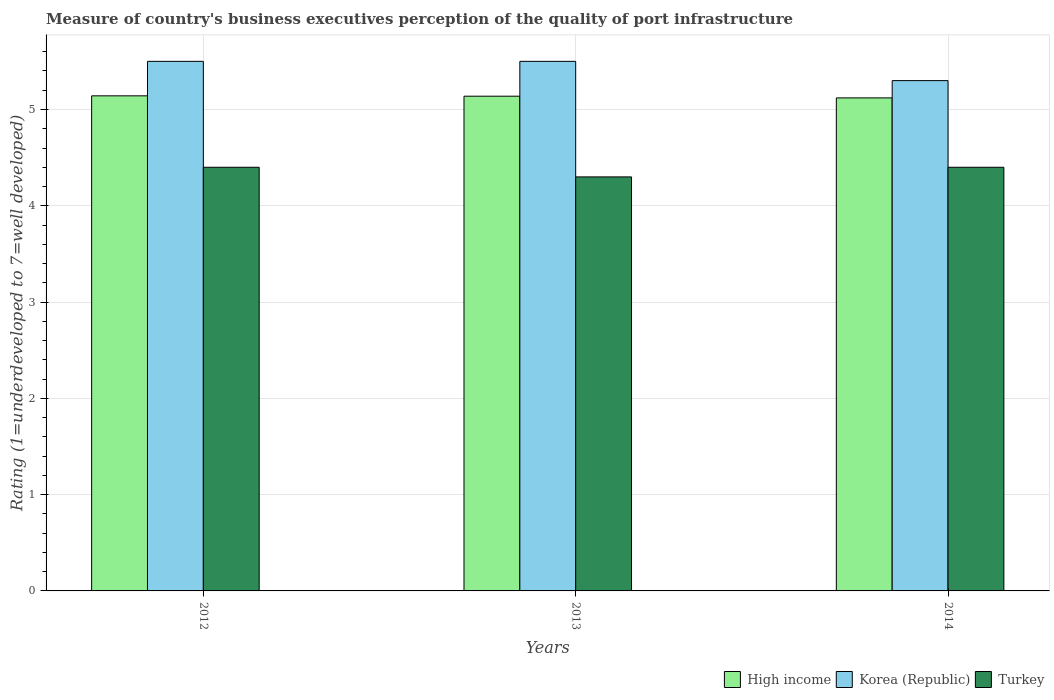How many different coloured bars are there?
Your answer should be very brief. 3. How many groups of bars are there?
Ensure brevity in your answer.  3. How many bars are there on the 3rd tick from the right?
Ensure brevity in your answer.  3. In how many cases, is the number of bars for a given year not equal to the number of legend labels?
Offer a very short reply. 0. What is the ratings of the quality of port infrastructure in High income in 2012?
Your answer should be very brief. 5.14. What is the difference between the ratings of the quality of port infrastructure in Korea (Republic) in 2013 and that in 2014?
Give a very brief answer. 0.2. What is the difference between the ratings of the quality of port infrastructure in Turkey in 2012 and the ratings of the quality of port infrastructure in Korea (Republic) in 2013?
Provide a succinct answer. -1.1. What is the average ratings of the quality of port infrastructure in Turkey per year?
Your response must be concise. 4.37. In the year 2014, what is the difference between the ratings of the quality of port infrastructure in High income and ratings of the quality of port infrastructure in Turkey?
Your response must be concise. 0.72. In how many years, is the ratings of the quality of port infrastructure in High income greater than 3.4?
Your response must be concise. 3. What is the ratio of the ratings of the quality of port infrastructure in Korea (Republic) in 2012 to that in 2014?
Your answer should be compact. 1.04. What is the difference between the highest and the second highest ratings of the quality of port infrastructure in High income?
Provide a short and direct response. 0. What is the difference between the highest and the lowest ratings of the quality of port infrastructure in Turkey?
Offer a terse response. 0.1. In how many years, is the ratings of the quality of port infrastructure in High income greater than the average ratings of the quality of port infrastructure in High income taken over all years?
Your response must be concise. 2. What does the 2nd bar from the left in 2014 represents?
Keep it short and to the point. Korea (Republic). What does the 3rd bar from the right in 2014 represents?
Provide a succinct answer. High income. Is it the case that in every year, the sum of the ratings of the quality of port infrastructure in Turkey and ratings of the quality of port infrastructure in Korea (Republic) is greater than the ratings of the quality of port infrastructure in High income?
Offer a terse response. Yes. How many bars are there?
Provide a succinct answer. 9. Are all the bars in the graph horizontal?
Provide a short and direct response. No. Are the values on the major ticks of Y-axis written in scientific E-notation?
Ensure brevity in your answer.  No. Where does the legend appear in the graph?
Make the answer very short. Bottom right. What is the title of the graph?
Your answer should be compact. Measure of country's business executives perception of the quality of port infrastructure. Does "Qatar" appear as one of the legend labels in the graph?
Your answer should be compact. No. What is the label or title of the Y-axis?
Your response must be concise. Rating (1=underdeveloped to 7=well developed). What is the Rating (1=underdeveloped to 7=well developed) in High income in 2012?
Offer a very short reply. 5.14. What is the Rating (1=underdeveloped to 7=well developed) in Turkey in 2012?
Provide a short and direct response. 4.4. What is the Rating (1=underdeveloped to 7=well developed) of High income in 2013?
Your response must be concise. 5.14. What is the Rating (1=underdeveloped to 7=well developed) of Turkey in 2013?
Give a very brief answer. 4.3. What is the Rating (1=underdeveloped to 7=well developed) of High income in 2014?
Keep it short and to the point. 5.12. What is the Rating (1=underdeveloped to 7=well developed) of Turkey in 2014?
Offer a very short reply. 4.4. Across all years, what is the maximum Rating (1=underdeveloped to 7=well developed) in High income?
Keep it short and to the point. 5.14. Across all years, what is the maximum Rating (1=underdeveloped to 7=well developed) of Korea (Republic)?
Provide a short and direct response. 5.5. Across all years, what is the minimum Rating (1=underdeveloped to 7=well developed) in High income?
Make the answer very short. 5.12. Across all years, what is the minimum Rating (1=underdeveloped to 7=well developed) of Korea (Republic)?
Provide a short and direct response. 5.3. What is the total Rating (1=underdeveloped to 7=well developed) of High income in the graph?
Your response must be concise. 15.4. What is the total Rating (1=underdeveloped to 7=well developed) of Turkey in the graph?
Keep it short and to the point. 13.1. What is the difference between the Rating (1=underdeveloped to 7=well developed) in High income in 2012 and that in 2013?
Offer a very short reply. 0. What is the difference between the Rating (1=underdeveloped to 7=well developed) in Korea (Republic) in 2012 and that in 2013?
Provide a succinct answer. 0. What is the difference between the Rating (1=underdeveloped to 7=well developed) of Turkey in 2012 and that in 2013?
Offer a very short reply. 0.1. What is the difference between the Rating (1=underdeveloped to 7=well developed) of High income in 2012 and that in 2014?
Your response must be concise. 0.02. What is the difference between the Rating (1=underdeveloped to 7=well developed) in Korea (Republic) in 2012 and that in 2014?
Make the answer very short. 0.2. What is the difference between the Rating (1=underdeveloped to 7=well developed) in Turkey in 2012 and that in 2014?
Your answer should be compact. 0. What is the difference between the Rating (1=underdeveloped to 7=well developed) of High income in 2013 and that in 2014?
Make the answer very short. 0.02. What is the difference between the Rating (1=underdeveloped to 7=well developed) of High income in 2012 and the Rating (1=underdeveloped to 7=well developed) of Korea (Republic) in 2013?
Offer a very short reply. -0.36. What is the difference between the Rating (1=underdeveloped to 7=well developed) in High income in 2012 and the Rating (1=underdeveloped to 7=well developed) in Turkey in 2013?
Provide a succinct answer. 0.84. What is the difference between the Rating (1=underdeveloped to 7=well developed) in Korea (Republic) in 2012 and the Rating (1=underdeveloped to 7=well developed) in Turkey in 2013?
Your answer should be very brief. 1.2. What is the difference between the Rating (1=underdeveloped to 7=well developed) in High income in 2012 and the Rating (1=underdeveloped to 7=well developed) in Korea (Republic) in 2014?
Give a very brief answer. -0.16. What is the difference between the Rating (1=underdeveloped to 7=well developed) in High income in 2012 and the Rating (1=underdeveloped to 7=well developed) in Turkey in 2014?
Offer a very short reply. 0.74. What is the difference between the Rating (1=underdeveloped to 7=well developed) of Korea (Republic) in 2012 and the Rating (1=underdeveloped to 7=well developed) of Turkey in 2014?
Give a very brief answer. 1.1. What is the difference between the Rating (1=underdeveloped to 7=well developed) in High income in 2013 and the Rating (1=underdeveloped to 7=well developed) in Korea (Republic) in 2014?
Your response must be concise. -0.16. What is the difference between the Rating (1=underdeveloped to 7=well developed) of High income in 2013 and the Rating (1=underdeveloped to 7=well developed) of Turkey in 2014?
Give a very brief answer. 0.74. What is the average Rating (1=underdeveloped to 7=well developed) in High income per year?
Offer a very short reply. 5.13. What is the average Rating (1=underdeveloped to 7=well developed) in Korea (Republic) per year?
Your answer should be compact. 5.43. What is the average Rating (1=underdeveloped to 7=well developed) in Turkey per year?
Your answer should be compact. 4.37. In the year 2012, what is the difference between the Rating (1=underdeveloped to 7=well developed) in High income and Rating (1=underdeveloped to 7=well developed) in Korea (Republic)?
Your answer should be compact. -0.36. In the year 2012, what is the difference between the Rating (1=underdeveloped to 7=well developed) in High income and Rating (1=underdeveloped to 7=well developed) in Turkey?
Provide a succinct answer. 0.74. In the year 2013, what is the difference between the Rating (1=underdeveloped to 7=well developed) of High income and Rating (1=underdeveloped to 7=well developed) of Korea (Republic)?
Ensure brevity in your answer.  -0.36. In the year 2013, what is the difference between the Rating (1=underdeveloped to 7=well developed) in High income and Rating (1=underdeveloped to 7=well developed) in Turkey?
Offer a terse response. 0.84. In the year 2013, what is the difference between the Rating (1=underdeveloped to 7=well developed) in Korea (Republic) and Rating (1=underdeveloped to 7=well developed) in Turkey?
Your answer should be compact. 1.2. In the year 2014, what is the difference between the Rating (1=underdeveloped to 7=well developed) of High income and Rating (1=underdeveloped to 7=well developed) of Korea (Republic)?
Give a very brief answer. -0.18. In the year 2014, what is the difference between the Rating (1=underdeveloped to 7=well developed) of High income and Rating (1=underdeveloped to 7=well developed) of Turkey?
Ensure brevity in your answer.  0.72. What is the ratio of the Rating (1=underdeveloped to 7=well developed) in Korea (Republic) in 2012 to that in 2013?
Offer a terse response. 1. What is the ratio of the Rating (1=underdeveloped to 7=well developed) in Turkey in 2012 to that in 2013?
Make the answer very short. 1.02. What is the ratio of the Rating (1=underdeveloped to 7=well developed) in Korea (Republic) in 2012 to that in 2014?
Provide a short and direct response. 1.04. What is the ratio of the Rating (1=underdeveloped to 7=well developed) in Korea (Republic) in 2013 to that in 2014?
Your answer should be compact. 1.04. What is the ratio of the Rating (1=underdeveloped to 7=well developed) in Turkey in 2013 to that in 2014?
Provide a succinct answer. 0.98. What is the difference between the highest and the second highest Rating (1=underdeveloped to 7=well developed) in High income?
Keep it short and to the point. 0. What is the difference between the highest and the second highest Rating (1=underdeveloped to 7=well developed) in Korea (Republic)?
Your answer should be compact. 0. What is the difference between the highest and the second highest Rating (1=underdeveloped to 7=well developed) of Turkey?
Your answer should be compact. 0. What is the difference between the highest and the lowest Rating (1=underdeveloped to 7=well developed) of High income?
Make the answer very short. 0.02. What is the difference between the highest and the lowest Rating (1=underdeveloped to 7=well developed) in Turkey?
Provide a succinct answer. 0.1. 